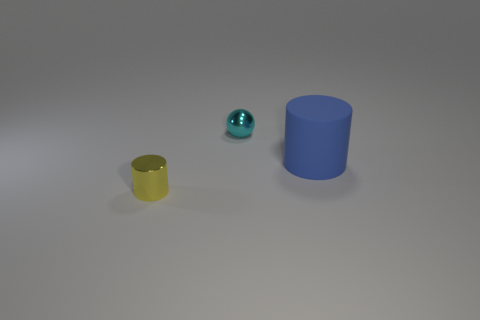Is the number of red rubber blocks greater than the number of big blue objects? no 